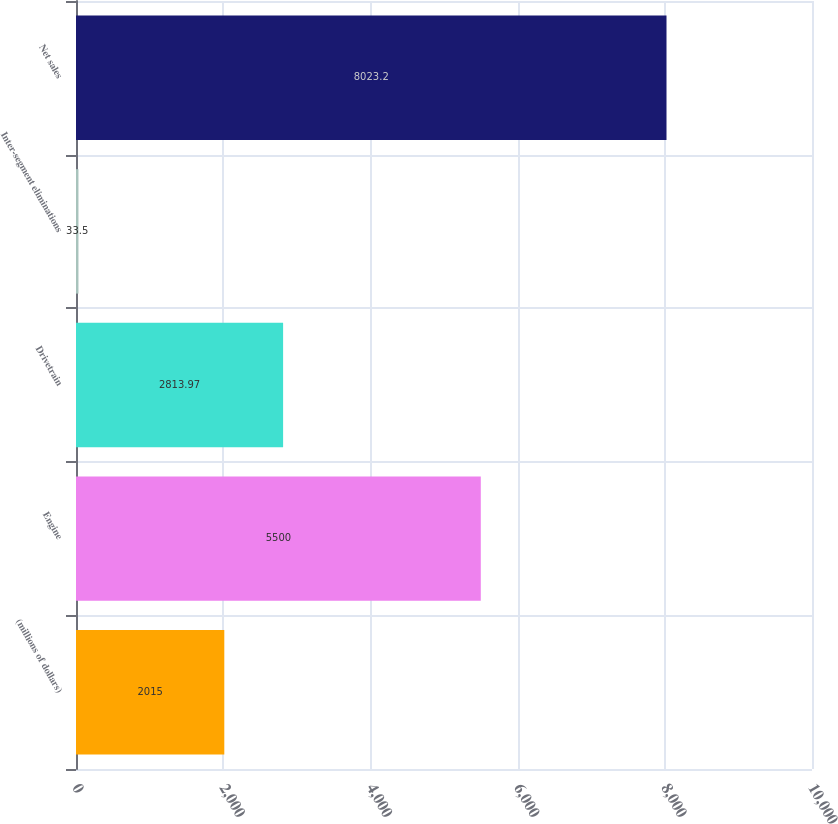Convert chart. <chart><loc_0><loc_0><loc_500><loc_500><bar_chart><fcel>(millions of dollars)<fcel>Engine<fcel>Drivetrain<fcel>Inter-segment eliminations<fcel>Net sales<nl><fcel>2015<fcel>5500<fcel>2813.97<fcel>33.5<fcel>8023.2<nl></chart> 